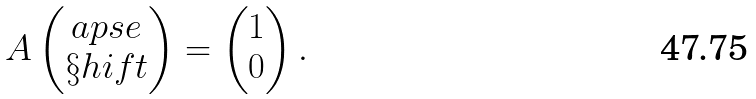Convert formula to latex. <formula><loc_0><loc_0><loc_500><loc_500>A \begin{pmatrix} \L a p s e \\ \S h i f t \end{pmatrix} = \begin{pmatrix} 1 \\ 0 \end{pmatrix} .</formula> 